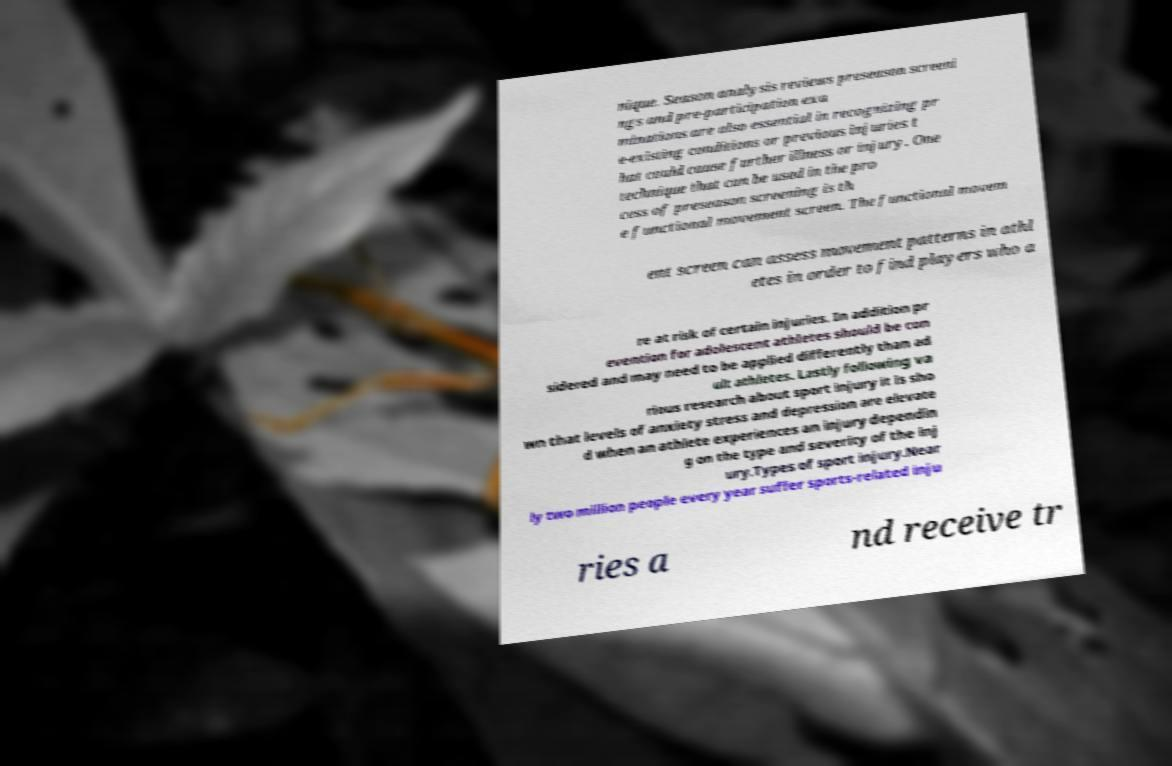Could you extract and type out the text from this image? nique. Season analysis reviews preseason screeni ngs and pre-participation exa minations are also essential in recognizing pr e-existing conditions or previous injuries t hat could cause further illness or injury. One technique that can be used in the pro cess of preseason screening is th e functional movement screen. The functional movem ent screen can assess movement patterns in athl etes in order to find players who a re at risk of certain injuries. In addition pr evention for adolescent athletes should be con sidered and may need to be applied differently than ad ult athletes. Lastly following va rious research about sport injury it is sho wn that levels of anxiety stress and depression are elevate d when an athlete experiences an injury dependin g on the type and severity of the inj ury.Types of sport injury.Near ly two million people every year suffer sports-related inju ries a nd receive tr 